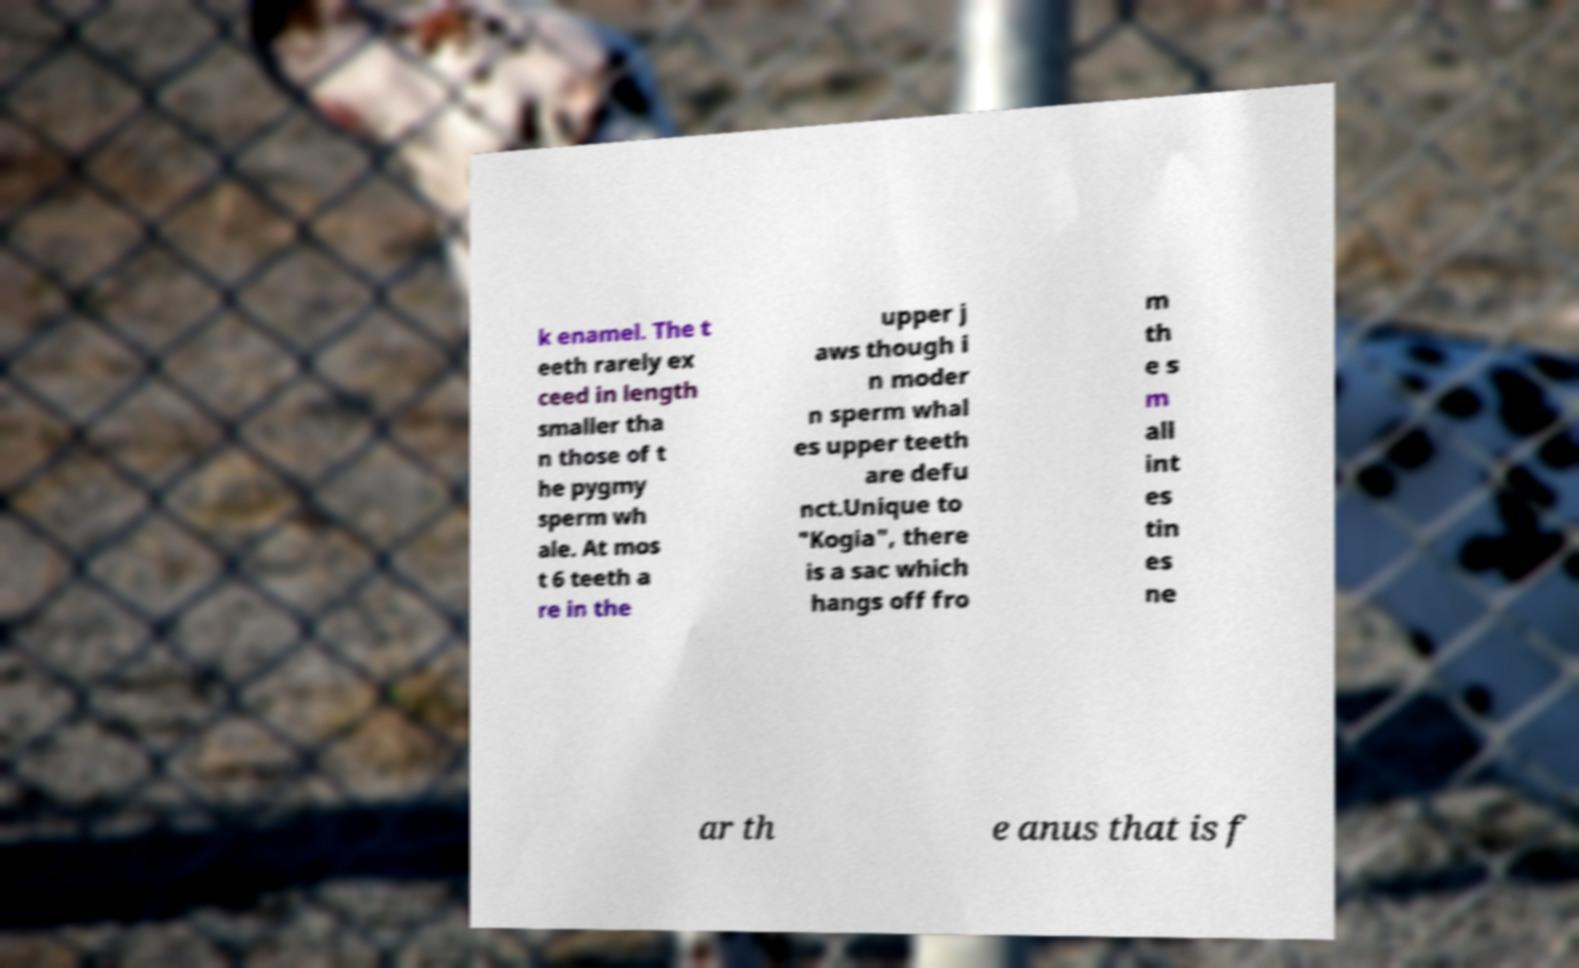There's text embedded in this image that I need extracted. Can you transcribe it verbatim? k enamel. The t eeth rarely ex ceed in length smaller tha n those of t he pygmy sperm wh ale. At mos t 6 teeth a re in the upper j aws though i n moder n sperm whal es upper teeth are defu nct.Unique to "Kogia", there is a sac which hangs off fro m th e s m all int es tin es ne ar th e anus that is f 